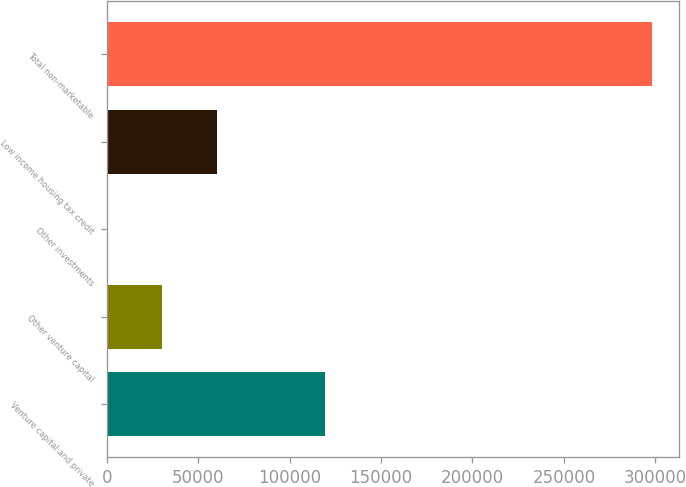Convert chart. <chart><loc_0><loc_0><loc_500><loc_500><bar_chart><fcel>Venture capital and private<fcel>Other venture capital<fcel>Other investments<fcel>Low income housing tax credit<fcel>Total non-marketable<nl><fcel>119543<fcel>30253.9<fcel>491<fcel>60016.8<fcel>298120<nl></chart> 